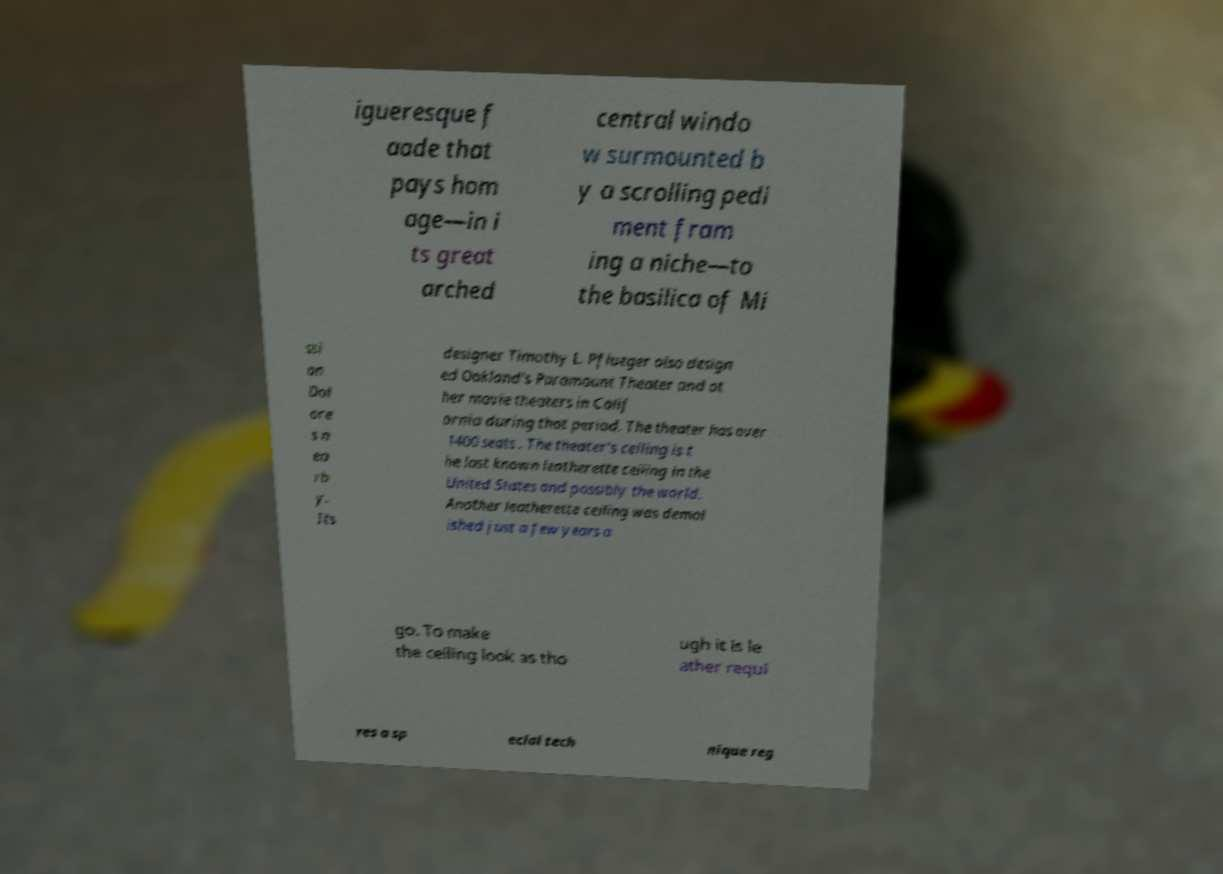Can you accurately transcribe the text from the provided image for me? igueresque f aade that pays hom age—in i ts great arched central windo w surmounted b y a scrolling pedi ment fram ing a niche—to the basilica of Mi ssi on Dol ore s n ea rb y. Its designer Timothy L. Pflueger also design ed Oakland's Paramount Theater and ot her movie theaters in Calif ornia during that period. The theater has over 1400 seats . The theater's ceiling is t he last known leatherette ceiling in the United States and possibly the world. Another leatherette ceiling was demol ished just a few years a go. To make the ceiling look as tho ugh it is le ather requi res a sp ecial tech nique reg 